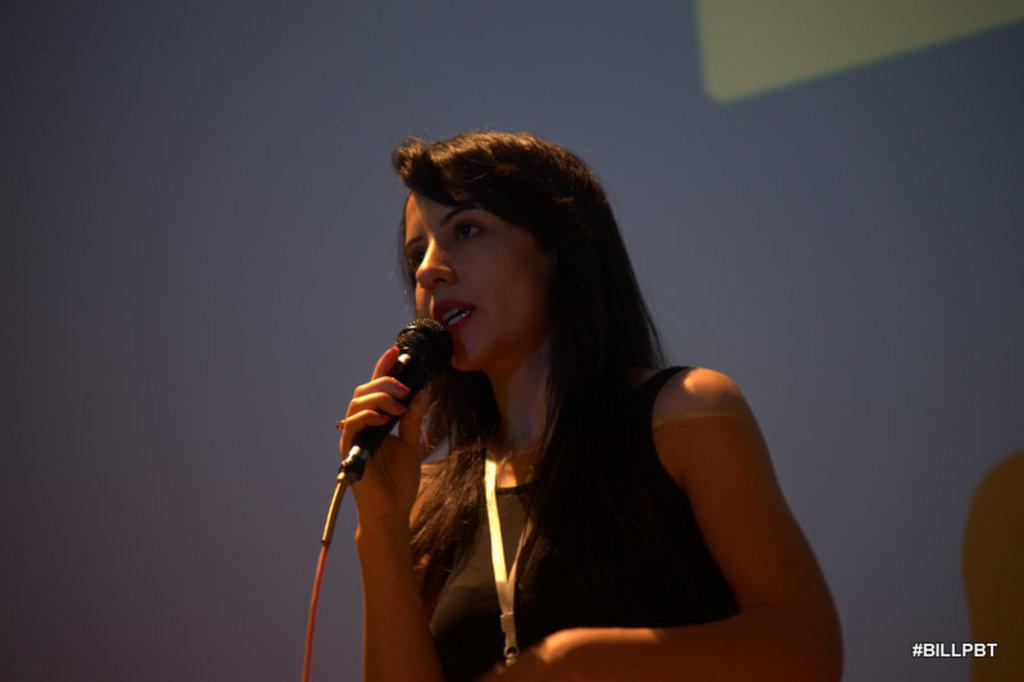Who is the main subject in the image? There is a woman in the image. What is the woman holding in her hand? The woman is holding a microphone in her hand. What is the woman doing in the image? The woman is talking. Is there any text visible in the image? Yes, there is some text visible in the bottom right of the image. What type of house is visible in the background of the image? There is no house visible in the background of the image. 